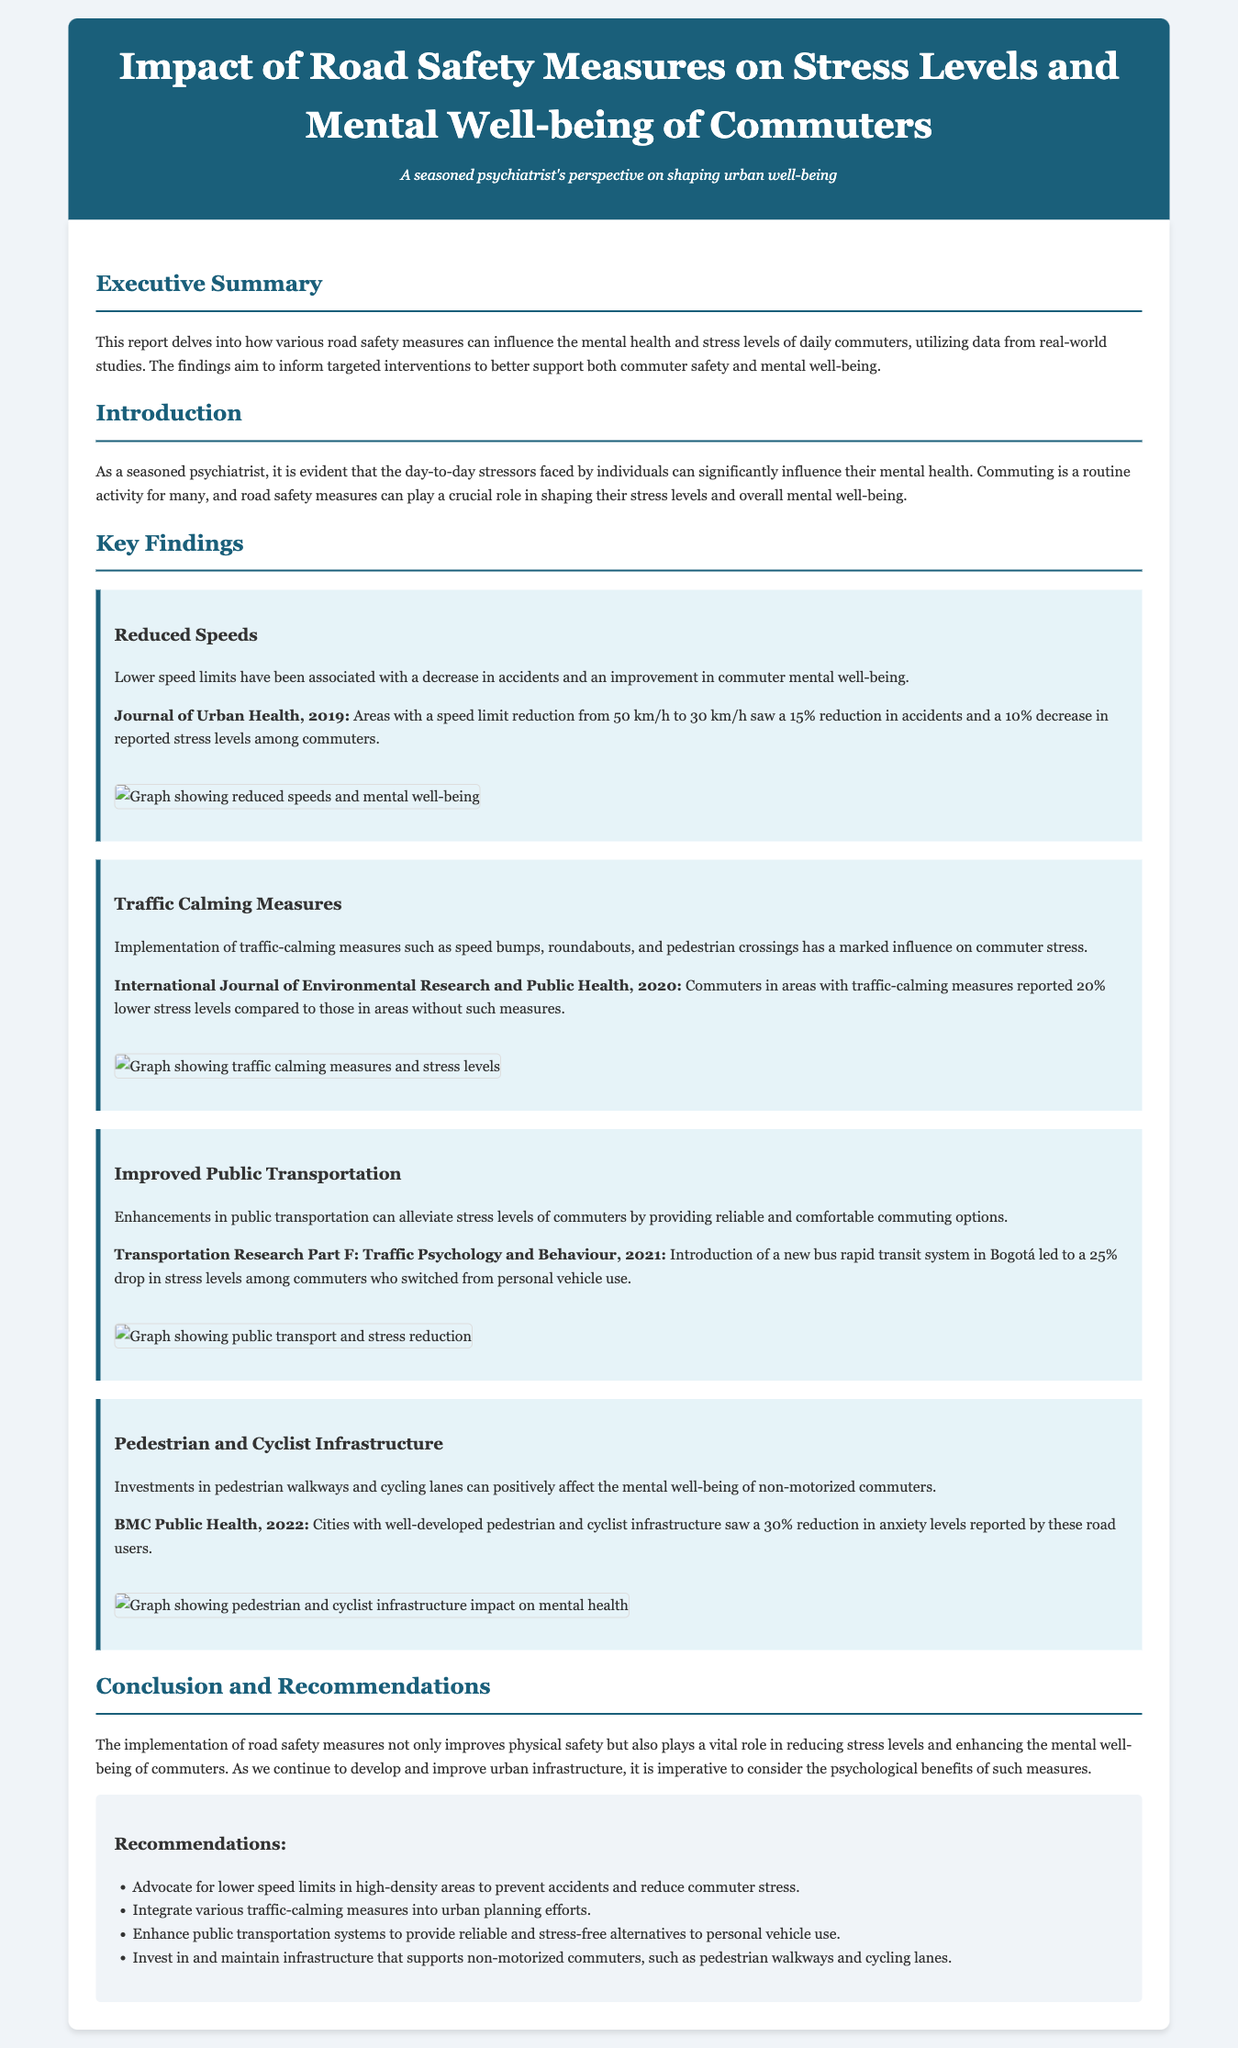what year was the report on reduced speeds published? The report cites a study published in the Journal of Urban Health in 2019 related to reduced speeds.
Answer: 2019 what was the percentage decrease in accidents with lower speed limits? The report states that there was a 15% reduction in accidents after a speed limit reduction.
Answer: 15% which journal published the findings on traffic calming measures? The document mentions that findings on traffic calming measures were published in the International Journal of Environmental Research and Public Health in 2020.
Answer: International Journal of Environmental Research and Public Health by what percentage did stress levels decrease for commuters using improved public transportation in Bogotá? According to the report, there was a 25% drop in stress levels among commuters who switched to the new bus rapid transit system.
Answer: 25% what type of infrastructure investments are mentioned as beneficial for non-motorized commuters? The report highlights investments in pedestrian walkways and cycling lanes as positive for the mental well-being of non-motorized commuters.
Answer: pedestrian walkways and cycling lanes what recommendation is made regarding speed limits in high-density areas? The report recommends advocating for lower speed limits in high-density areas to prevent accidents and reduce commuter stress.
Answer: lower speed limits what psychological impact do traffic-calming measures have according to the findings? The findings indicate that traffic-calming measures lead to 20% lower stress levels for commuters in those areas.
Answer: 20% lower stress levels which publication discussed the impact of pedestrian and cyclist infrastructure on anxiety levels? The report cites BMC Public Health, 2022, as the source discussing the impact of pedestrian and cyclist infrastructure.
Answer: BMC Public Health, 2022 